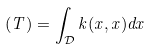<formula> <loc_0><loc_0><loc_500><loc_500>( T ) = \int _ { \mathcal { D } } k ( x , x ) d x</formula> 